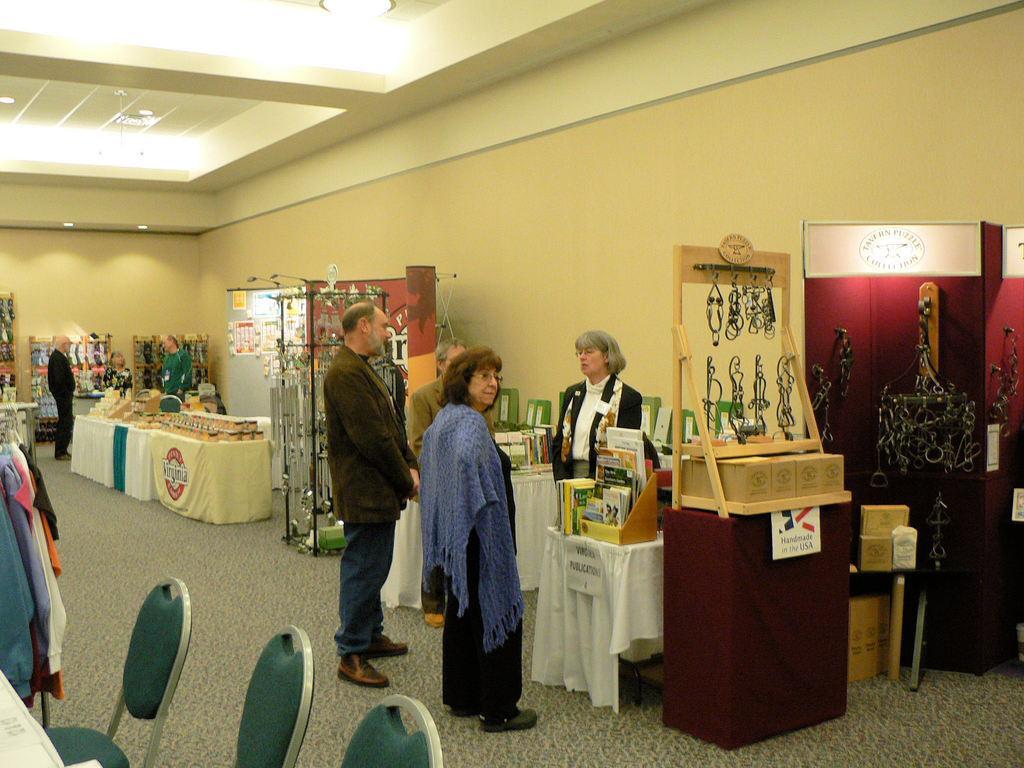Describe this image in one or two sentences. In this picture we can see people on the floor, here we can see tables, chairs, clothes and some objects and in the background we can see a wall, lights. 